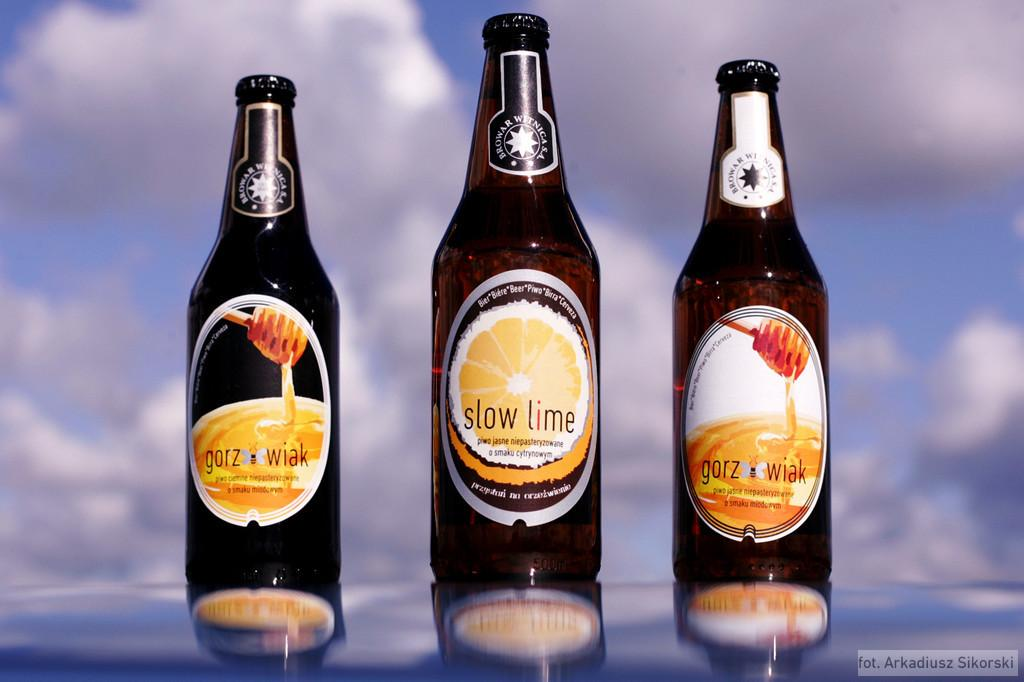<image>
Share a concise interpretation of the image provided. three bottles standing next to each other with one that is labeled 'slow lime' 